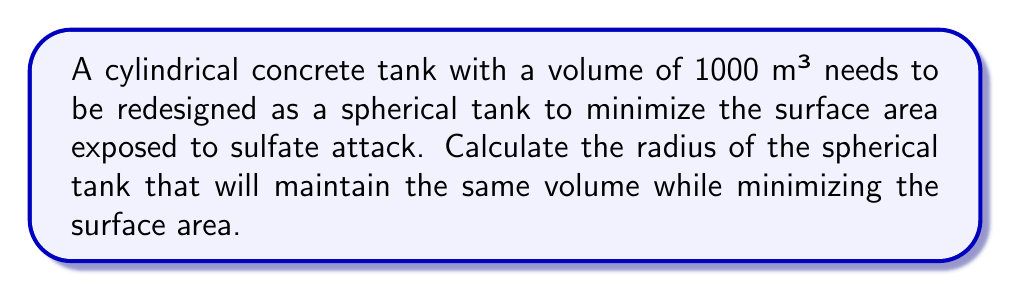Give your solution to this math problem. To solve this problem, we'll follow these steps:

1. Recall the formulas for the volume and surface area of a sphere:
   Volume: $V = \frac{4}{3}\pi r^3$
   Surface Area: $A = 4\pi r^2$

2. Given the volume of 1000 m³, we can set up the equation:
   $1000 = \frac{4}{3}\pi r^3$

3. Solve for $r$:
   $$\begin{align}
   1000 &= \frac{4}{3}\pi r^3 \\
   750 &= \pi r^3 \\
   r^3 &= \frac{750}{\pi} \\
   r &= \sqrt[3]{\frac{750}{\pi}}
   \end{align}$$

4. Calculate the value of $r$:
   $r \approx 6.2035$ m

5. To verify that this indeed minimizes the surface area, we can compare it to slightly larger or smaller radii while maintaining the same volume. This spherical shape will have the minimum surface area for the given volume due to the isoperimetric inequality, which states that the sphere has the smallest surface area among all shapes with a given volume.
Answer: $r \approx 6.2035$ m 